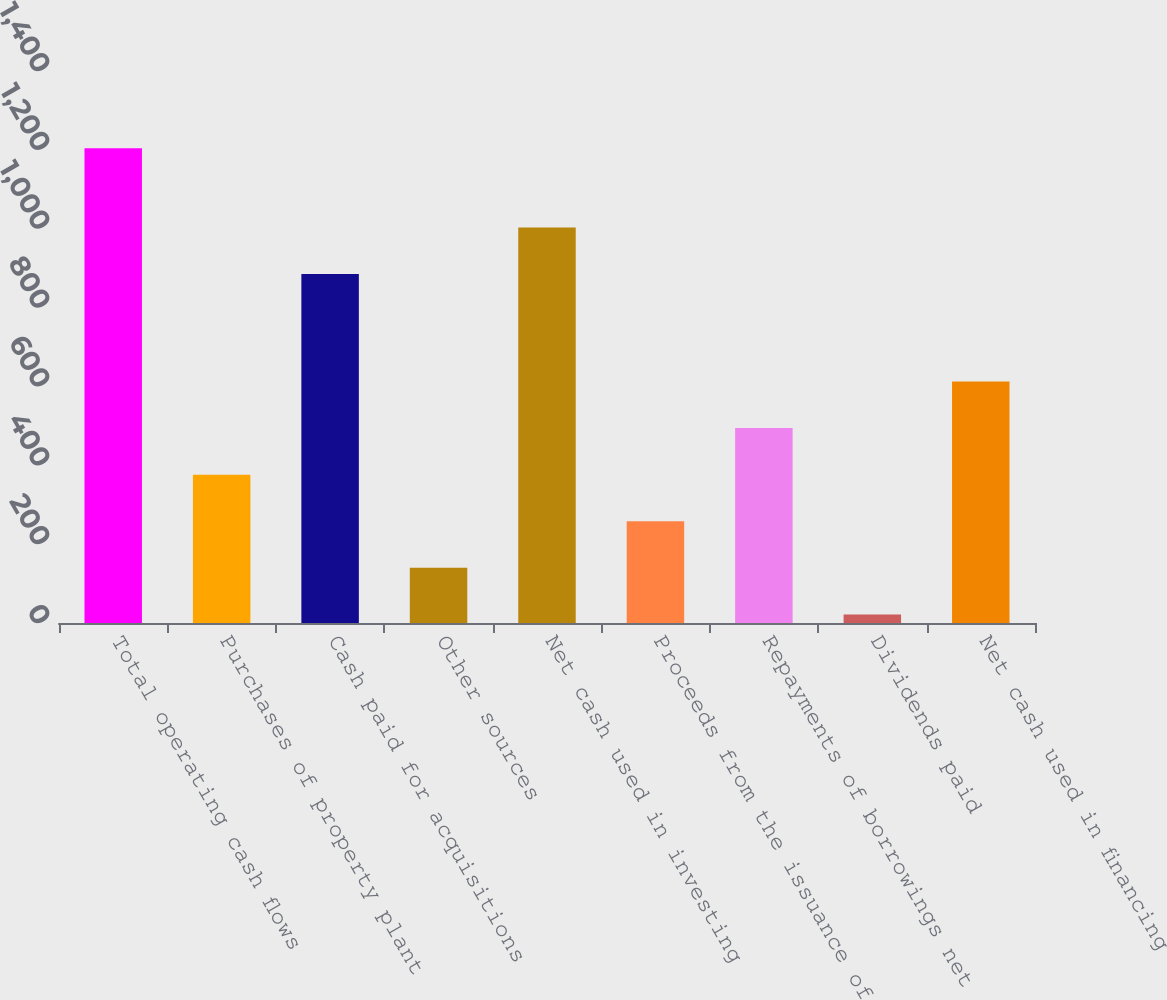Convert chart to OTSL. <chart><loc_0><loc_0><loc_500><loc_500><bar_chart><fcel>Total operating cash flows<fcel>Purchases of property plant<fcel>Cash paid for acquisitions<fcel>Other sources<fcel>Net cash used in investing<fcel>Proceeds from the issuance of<fcel>Repayments of borrowings net<fcel>Dividends paid<fcel>Net cash used in financing<nl><fcel>1203.8<fcel>376.26<fcel>885.1<fcel>139.82<fcel>1003.32<fcel>258.04<fcel>494.48<fcel>21.6<fcel>612.7<nl></chart> 